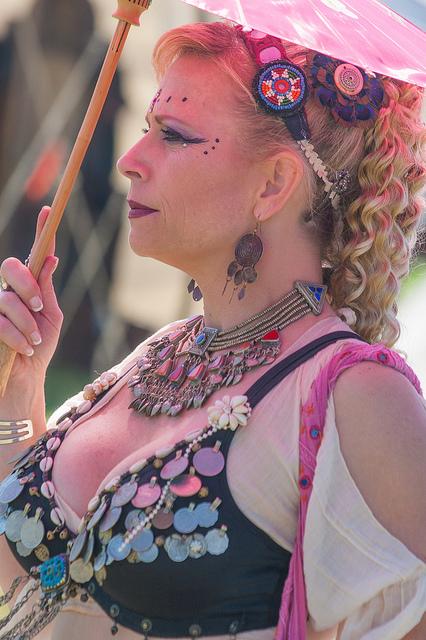Is the woman wearing jewelry?
Give a very brief answer. Yes. What color is the umbrella?
Give a very brief answer. Pink. What is the woman holding?
Be succinct. Umbrella. 